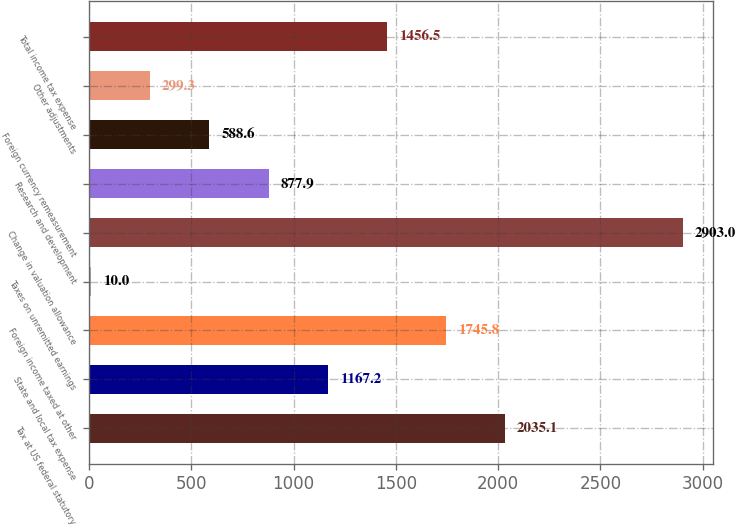Convert chart. <chart><loc_0><loc_0><loc_500><loc_500><bar_chart><fcel>Tax at US federal statutory<fcel>State and local tax expense<fcel>Foreign income taxed at other<fcel>Taxes on unremitted earnings<fcel>Change in valuation allowance<fcel>Research and development<fcel>Foreign currency remeasurement<fcel>Other adjustments<fcel>Total income tax expense<nl><fcel>2035.1<fcel>1167.2<fcel>1745.8<fcel>10<fcel>2903<fcel>877.9<fcel>588.6<fcel>299.3<fcel>1456.5<nl></chart> 